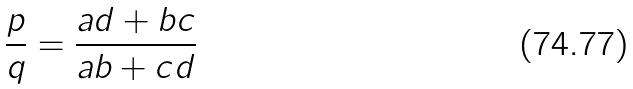Convert formula to latex. <formula><loc_0><loc_0><loc_500><loc_500>\frac { p } { q } = \frac { a d + b c } { a b + c d }</formula> 